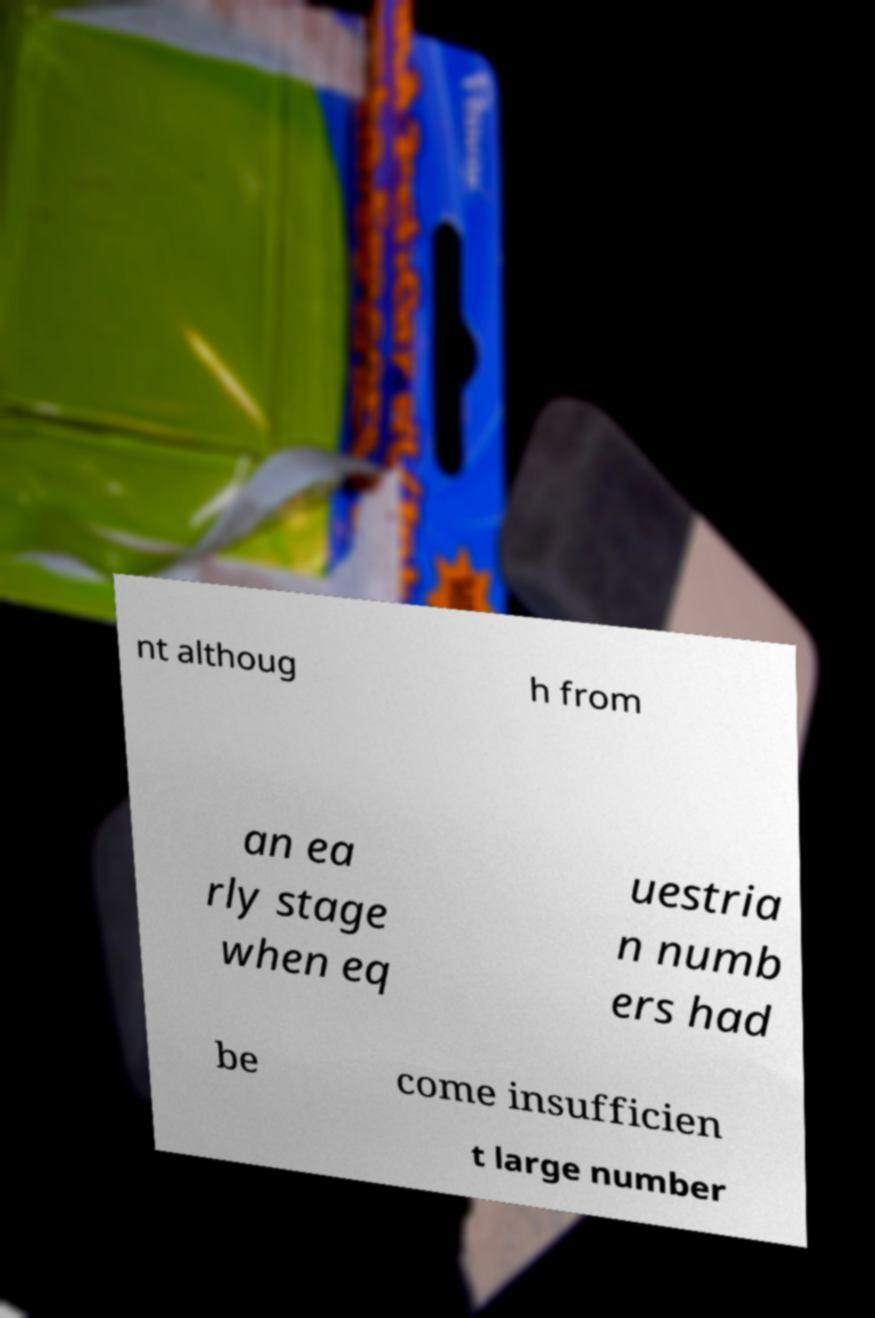Can you read and provide the text displayed in the image?This photo seems to have some interesting text. Can you extract and type it out for me? nt althoug h from an ea rly stage when eq uestria n numb ers had be come insufficien t large number 